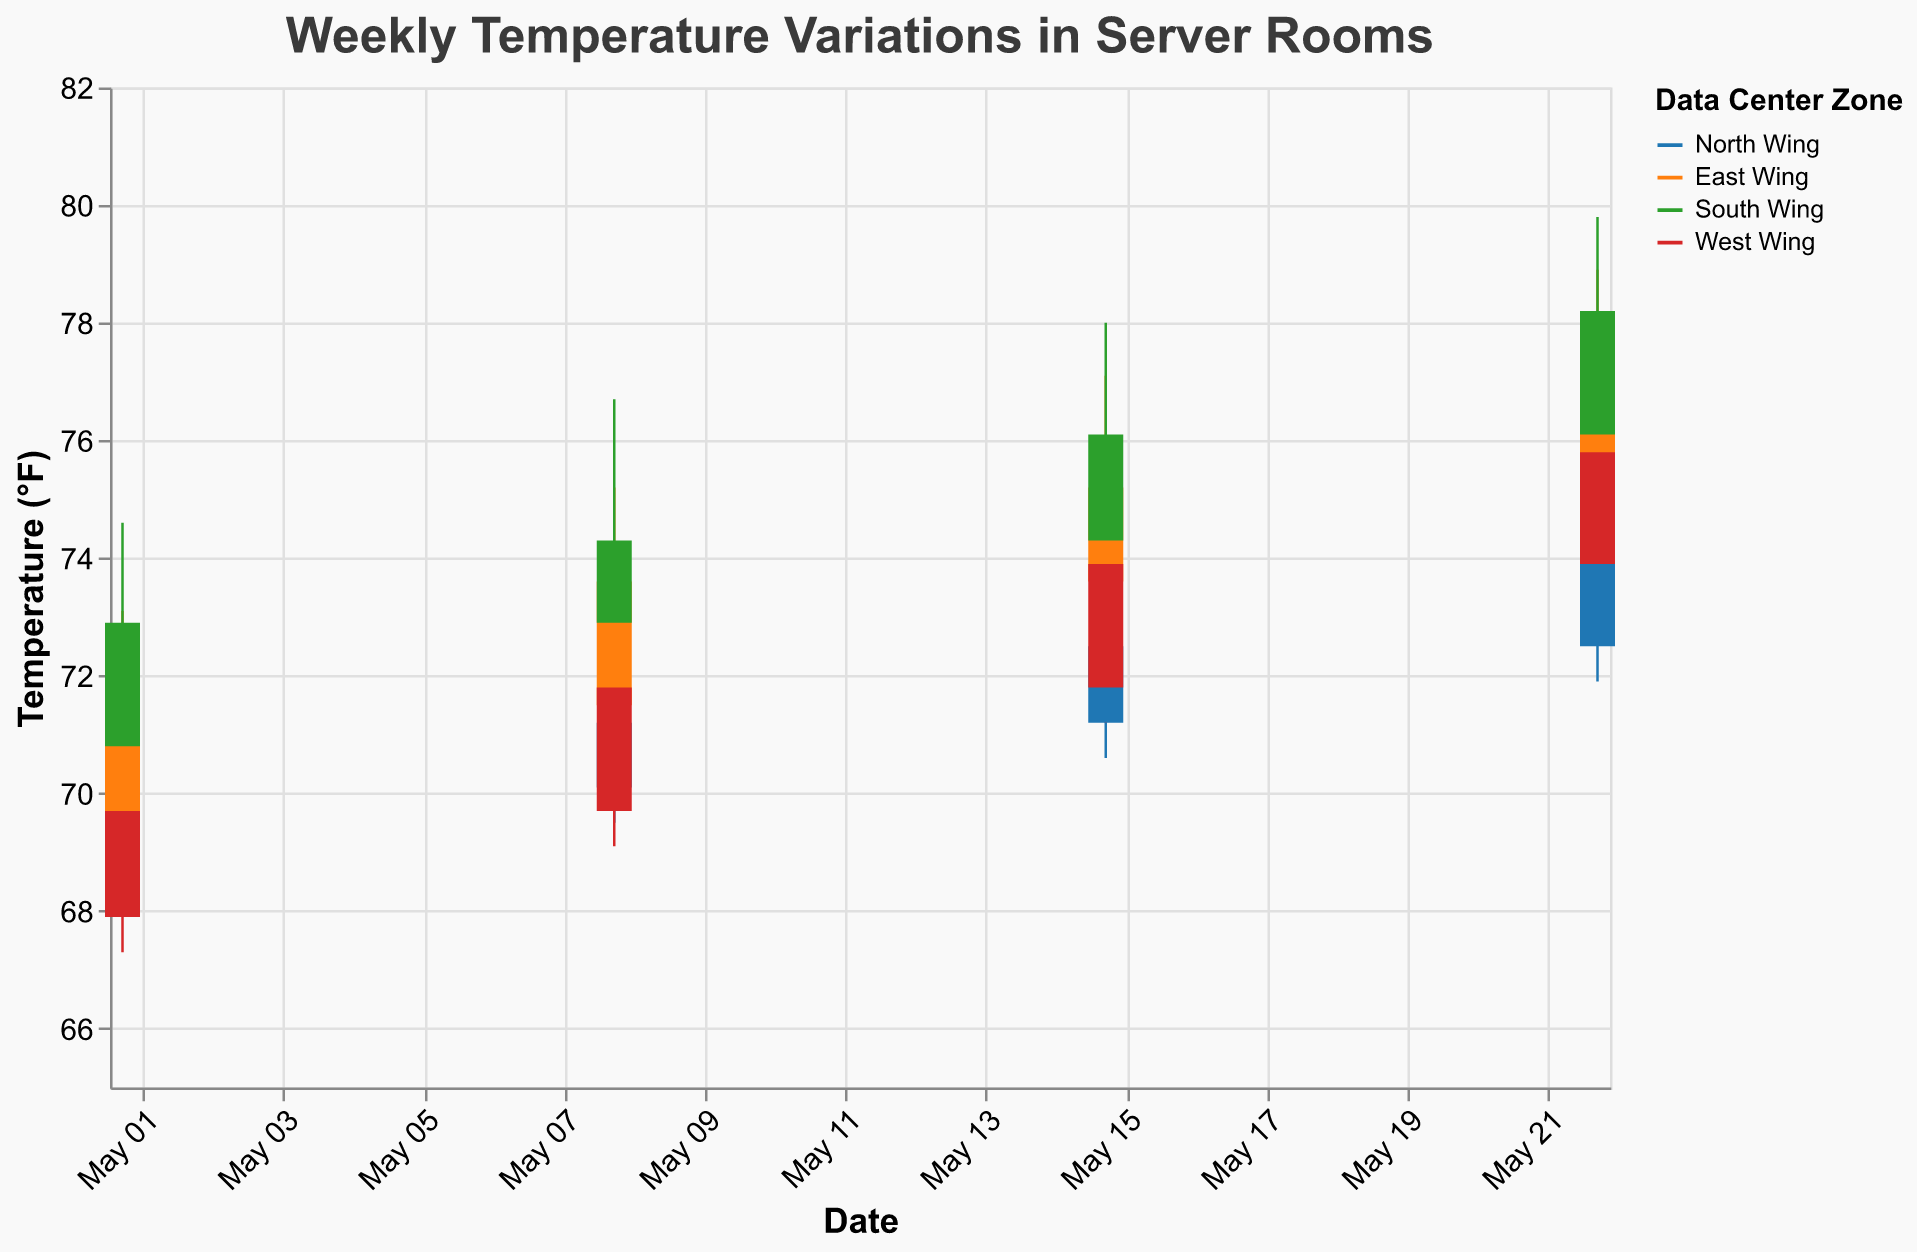What is the title of the chart? The title is prominently displayed at the top of the chart, describing the data shown. It reads: "Weekly Temperature Variations in Server Rooms".
Answer: Weekly Temperature Variations in Server Rooms Which Zone experienced the highest high temperature on May 22? Looking at May 22 data and comparing the high temperatures for all zones, the South Wing recorded the highest high temperature at 79.8°F.
Answer: South Wing What was the temperature range (High-Low) for the East Wing on May 15? The high temperature for the East Wing on May 15 was 77.1°F, and the low temperature was 72.9°F. The range is calculated by subtracting the low from the high: 77.1 - 72.9 = 4.2°F.
Answer: 4.2°F Which Zone had the lowest closing temperature on May 8? On May 8, the West Wing had the lowest closing temperature at 71.8°F.
Answer: West Wing How did the opening and closing temperatures for the North Wing change from May 8 to May 15? For the North Wing, on May 8, the opening temperature was 70.1°F, and the closing temperature was 71.2°F. On May 15, the opening temperature was 71.2°F, and the closing temperature was 72.5°F. The opening temperature increased by 71.2 - 70.1 = 1.1°F, and the closing temperature increased by 72.5 - 71.2 = 1.3°F.
Answer: Opening +1.1°F, Closing +1.3°F Which Zone had the smallest difference between its highest and lowest temperatures on May 1? Comparing the difference (High-Low) for all zones on May 1: 
- North Wing: 72.3 - 67.9 = 4.4°F
- East Wing: 73.1 - 68.7 = 4.4°F
- South Wing: 74.6 - 70.2 = 4.4°F
- West Wing: 71.8 - 67.3 = 4.5°F
The smallest difference is the same for North, East, and South Wing at 4.4°F.
Answer: North Wing, East Wing, and South Wing On which date did the West Wing have the highest closing temperature? Analyzing the closing temperatures for the West Wing across the dates:
- May 1: 69.7°F
- May 8: 71.8°F
- May 15: 73.9°F
- May 22: 75.8°F
The highest closing temperature for the West Wing was on May 22 at 75.8°F.
Answer: May 22 How much did the closing temperature in the South Wing increase from May 1 to May 22? The closing temperature in the South Wing on May 1 was 72.9°F and on May 22 was 78.2°F. The increase is calculated as 78.2 - 72.9 = 5.3°F.
Answer: 5.3°F Which Zone had the highest increase in closing temperature between May 1 and May 22? By calculating the closing temperature increase for each zone from May 1 to May 22:
- North Wing: 74.1 - 70.1 = 4.0°F
- East Wing: 77.3 - 71.5 = 5.8°F
- South Wing: 78.2 - 72.9 = 5.3°F
- West Wing: 75.8 - 69.7 = 6.1°F
The West Wing had the highest increase at 6.1°F.
Answer: West Wing 